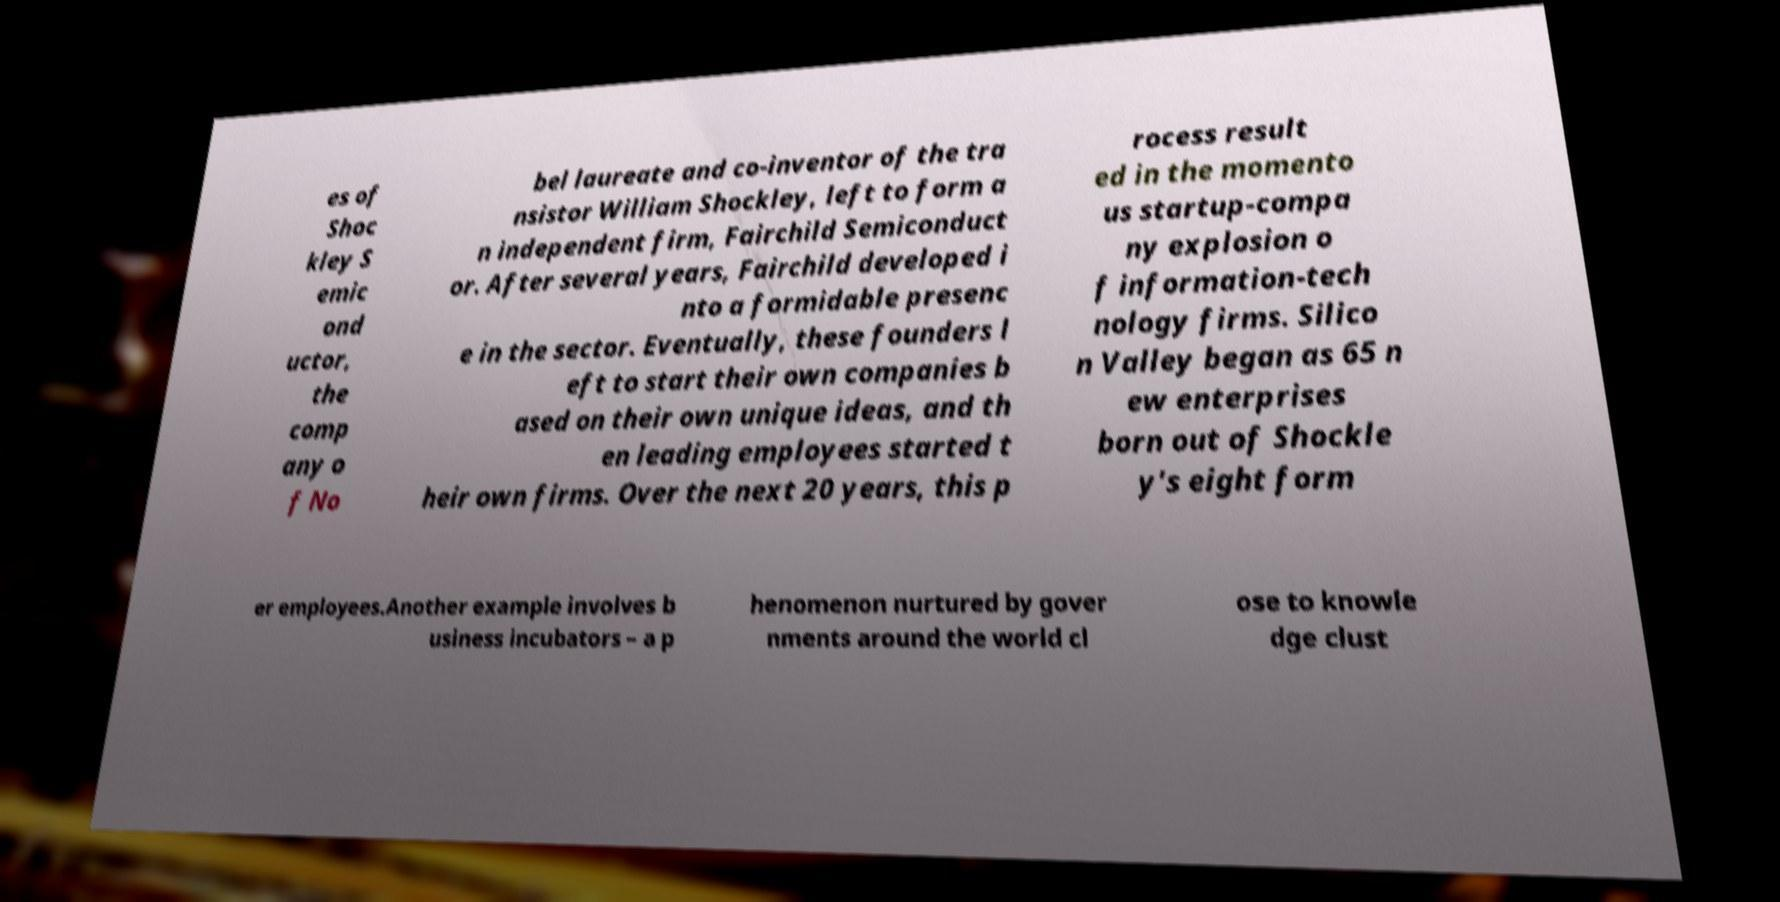Please read and relay the text visible in this image. What does it say? es of Shoc kley S emic ond uctor, the comp any o f No bel laureate and co-inventor of the tra nsistor William Shockley, left to form a n independent firm, Fairchild Semiconduct or. After several years, Fairchild developed i nto a formidable presenc e in the sector. Eventually, these founders l eft to start their own companies b ased on their own unique ideas, and th en leading employees started t heir own firms. Over the next 20 years, this p rocess result ed in the momento us startup-compa ny explosion o f information-tech nology firms. Silico n Valley began as 65 n ew enterprises born out of Shockle y's eight form er employees.Another example involves b usiness incubators – a p henomenon nurtured by gover nments around the world cl ose to knowle dge clust 